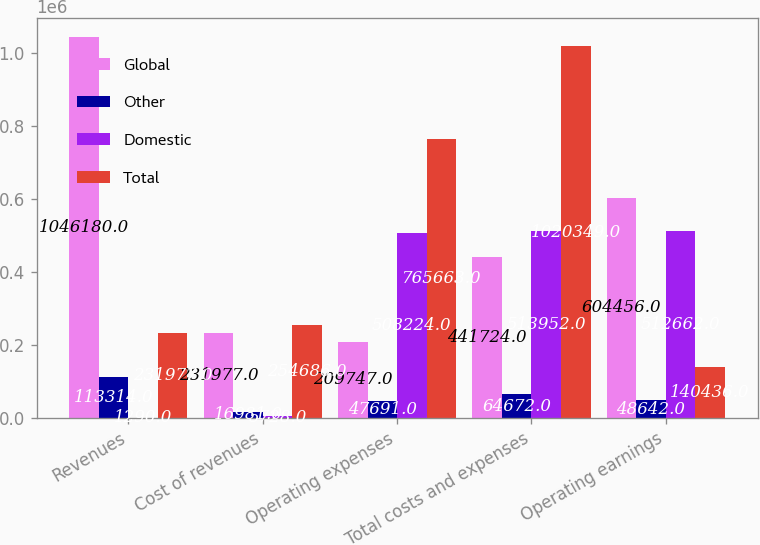Convert chart. <chart><loc_0><loc_0><loc_500><loc_500><stacked_bar_chart><ecel><fcel>Revenues<fcel>Cost of revenues<fcel>Operating expenses<fcel>Total costs and expenses<fcel>Operating earnings<nl><fcel>Global<fcel>1.04618e+06<fcel>231977<fcel>209747<fcel>441724<fcel>604456<nl><fcel>Other<fcel>113314<fcel>16981<fcel>47691<fcel>64672<fcel>48642<nl><fcel>Domestic<fcel>1290<fcel>5728<fcel>508224<fcel>513952<fcel>512662<nl><fcel>Total<fcel>231977<fcel>254686<fcel>765663<fcel>1.02035e+06<fcel>140436<nl></chart> 